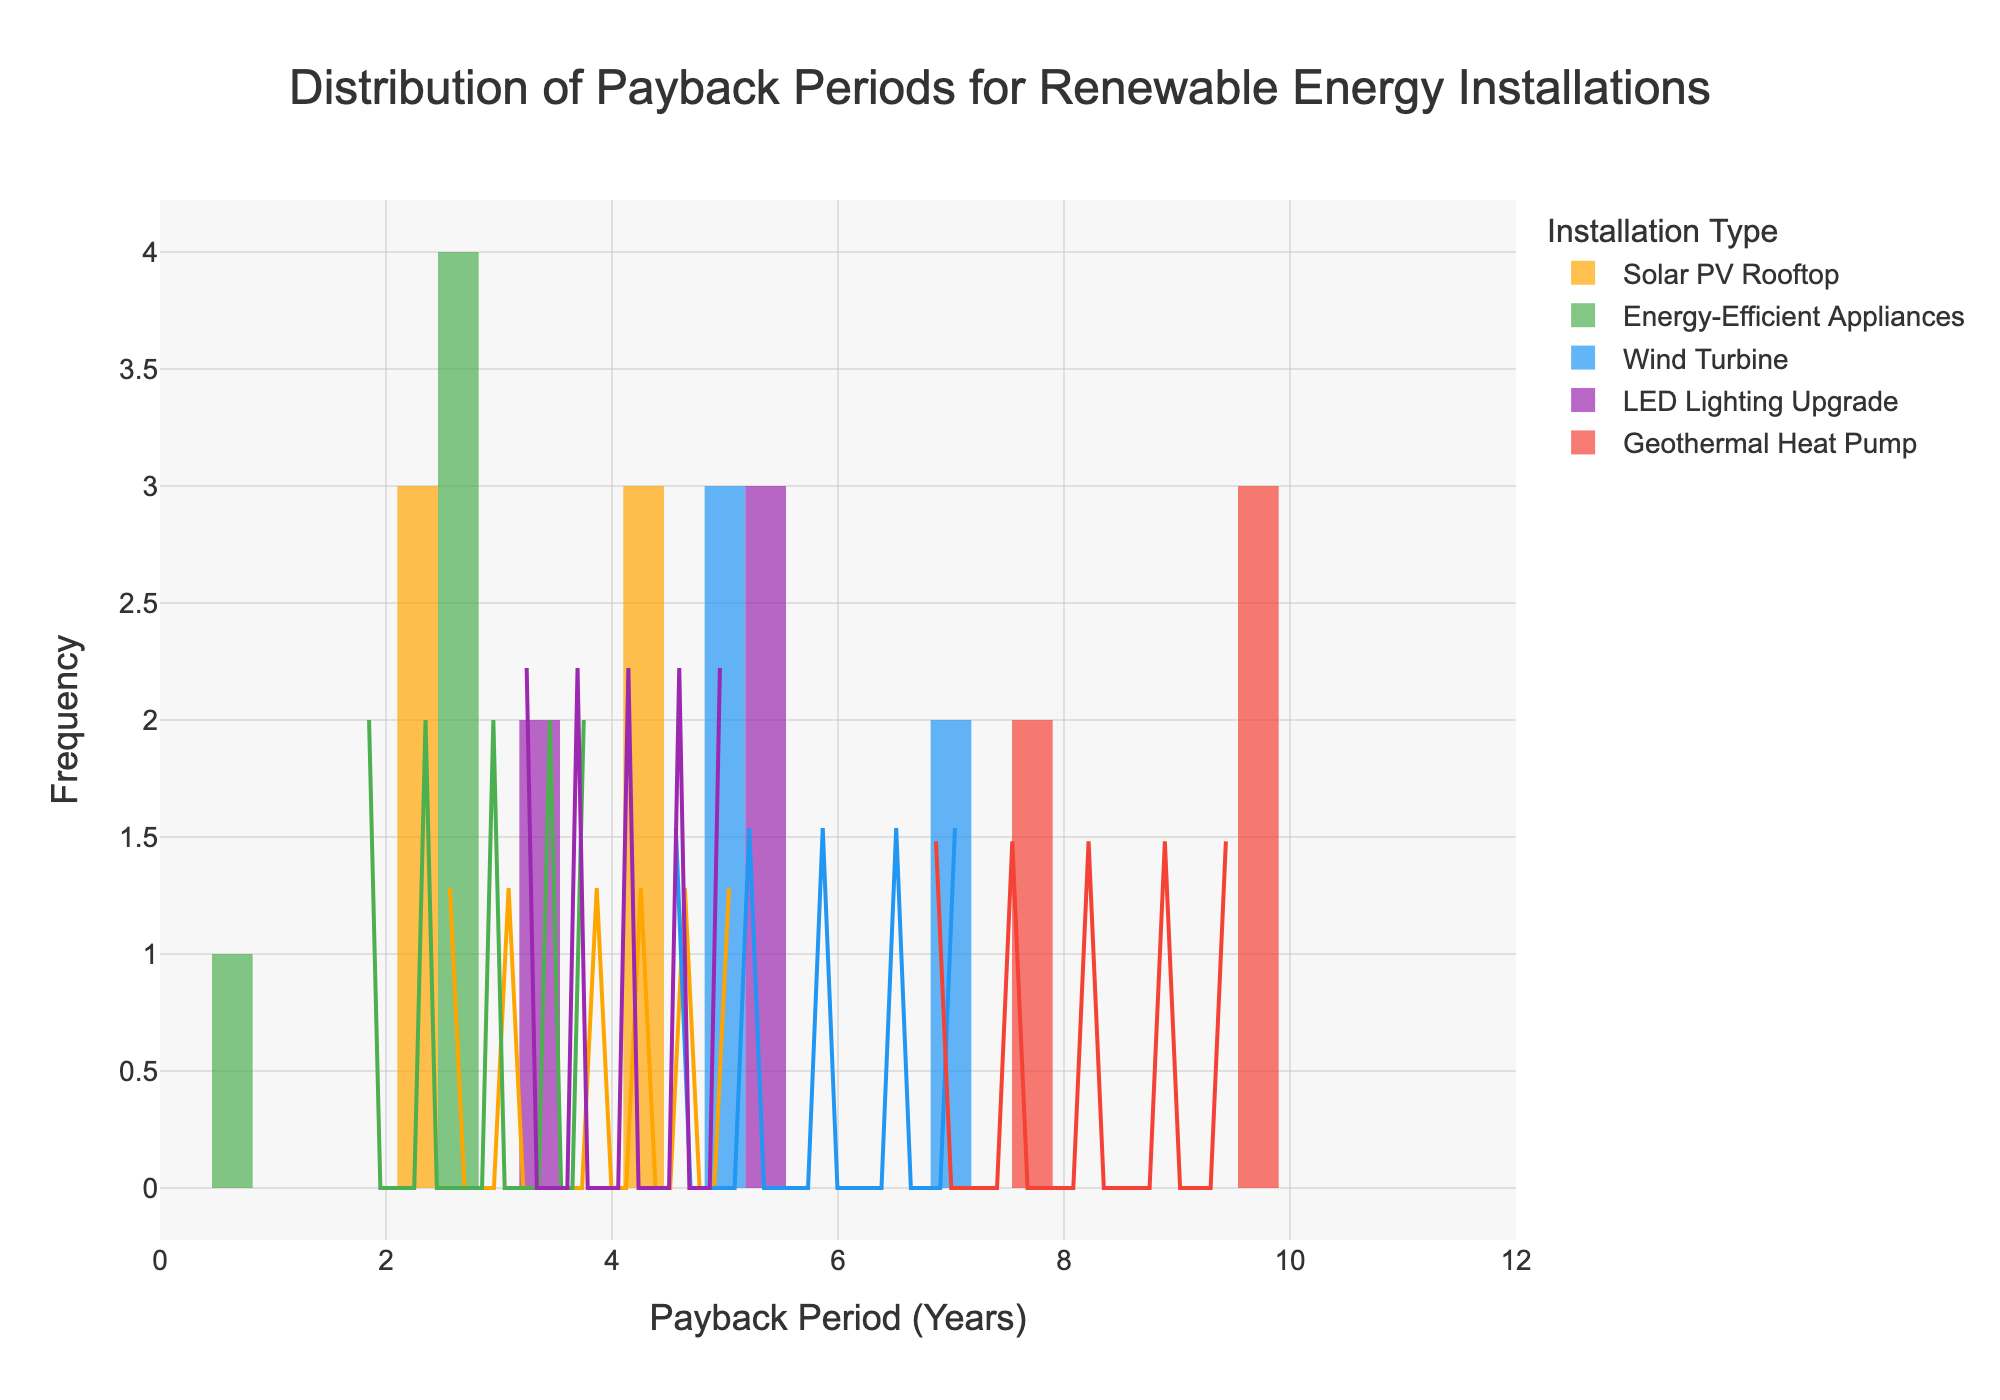What is the title of the figure? The title can be found at the top of the figure, which usually describes the purpose or content of the plot.
Answer: Distribution of Payback Periods for Renewable Energy Installations What is the range of the x-axis? By observing the x-axis, we can see the minimum and maximum values it covers.
Answer: 0 to 12 Which installation type has the shortest payback periods? The shortest payback periods can be identified where the histogram bars are positioned furthest to the left on the x-axis. The KDE curve corresponding to these bars will also peak earliest.
Answer: Energy-Efficient Appliances What is the highest payback period observed for a Solar PV Rooftop installation? By looking at the histogram bars and KDE curve for the Solar PV Rooftop, we identify the highest x-axis value for this installation type.
Answer: 5.1 years Which installation type has the most varied payback periods? The installation type with the most varied payback periods will have a wider spread of histogram bars and KDE curve, covering a larger range on the x-axis.
Answer: Geothermal Heat Pump Are the payback periods for Wind Turbine installations greater on average compared to Solar PV Rooftop installations? By comparing the central tendencies and peaks of the KDE curves for Wind Turbine and Solar PV Rooftop, we can judge if one mean is greater than the other.
Answer: Yes How many installation types have their highest payback periods in the range 3 to 5 years? Count the number of installation types whose histogram bars have significant height within the range of 3 to 5 years.
Answer: Three (Solar PV Rooftop, Energy-Efficient Appliances, LED Lighting Upgrade) Which installation type has the KDE curve peak furthest to the right? The KDE curve peak furthest to the right corresponds to the installation type with the highest average payback period.
Answer: Geothermal Heat Pump Is the distribution of payback periods for Solar PV Rooftop installations unimodal or multimodal? By observing the KDE curve for Solar PV Rooftop, we determine whether it has one peak (unimodal) or multiple peaks (multimodal).
Answer: Unimodal What is a major visual difference between the distributions of Solar PV Rooftop and Wind Turbine installations? By comparing the two sets of histogram bars and KDE curves, identify a key difference in their visual distribution, such as spread or peak position.
Answer: Wind Turbine has a wider spread and a higher peak at longer payback periods compared to Solar PV Rooftop 